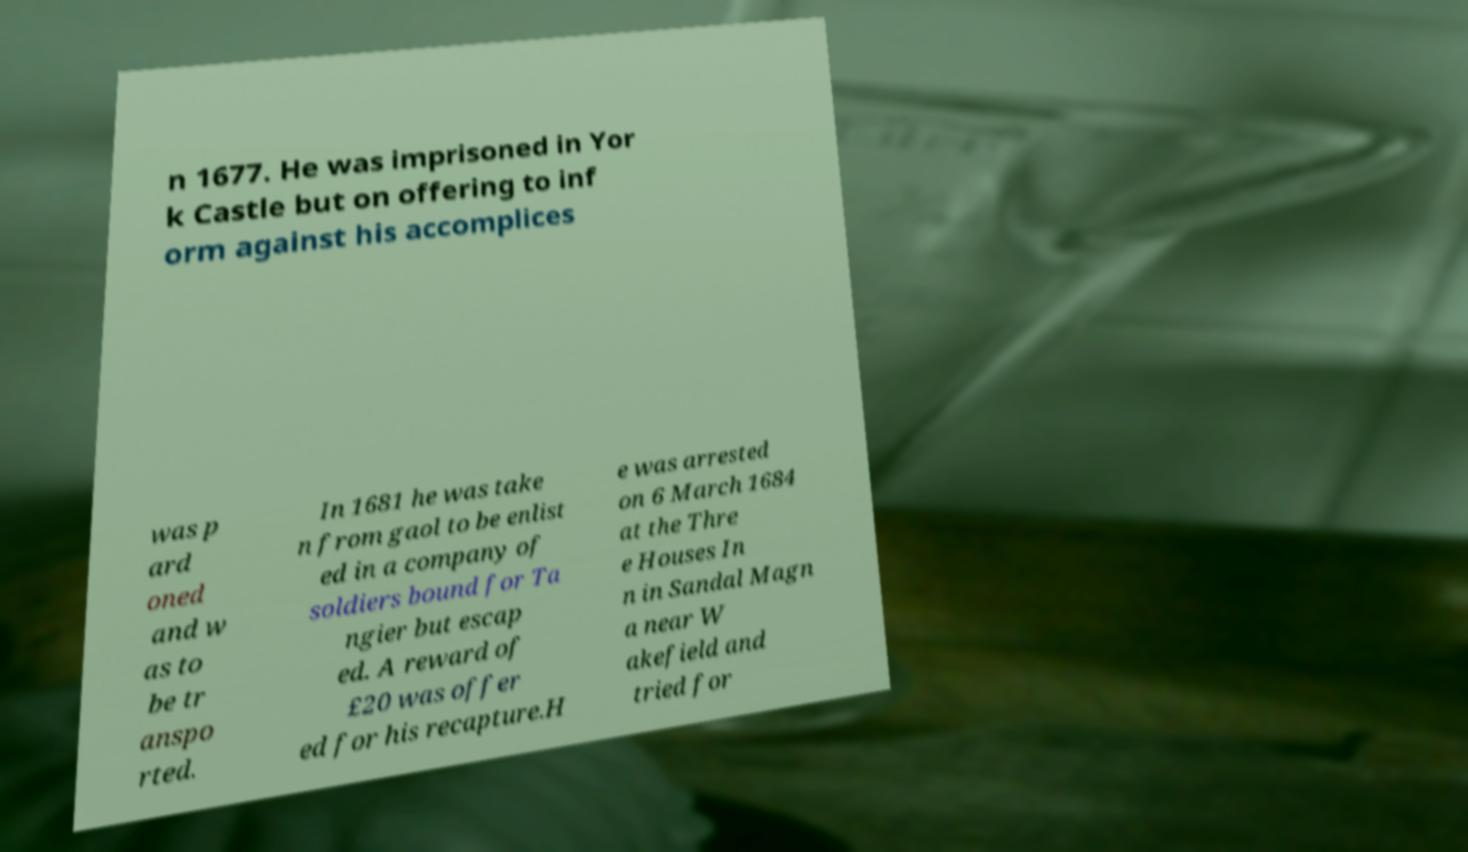I need the written content from this picture converted into text. Can you do that? n 1677. He was imprisoned in Yor k Castle but on offering to inf orm against his accomplices was p ard oned and w as to be tr anspo rted. In 1681 he was take n from gaol to be enlist ed in a company of soldiers bound for Ta ngier but escap ed. A reward of £20 was offer ed for his recapture.H e was arrested on 6 March 1684 at the Thre e Houses In n in Sandal Magn a near W akefield and tried for 